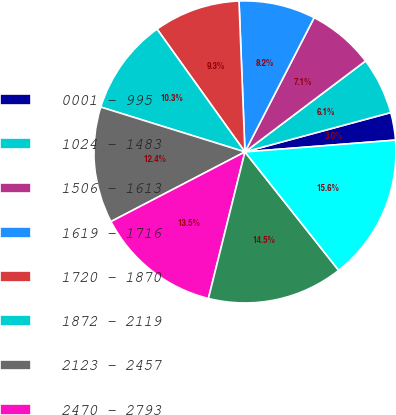Convert chart. <chart><loc_0><loc_0><loc_500><loc_500><pie_chart><fcel>0001 - 995<fcel>1024 - 1483<fcel>1506 - 1613<fcel>1619 - 1716<fcel>1720 - 1870<fcel>1872 - 2119<fcel>2123 - 2457<fcel>2470 - 2793<fcel>2806 - 2988<fcel>3000 - 5458<nl><fcel>2.95%<fcel>6.09%<fcel>7.14%<fcel>8.2%<fcel>9.26%<fcel>10.31%<fcel>12.43%<fcel>13.48%<fcel>14.54%<fcel>15.59%<nl></chart> 